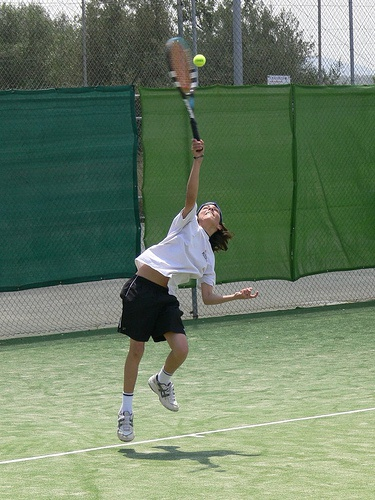Describe the objects in this image and their specific colors. I can see people in white, black, darkgray, and gray tones, tennis racket in white, gray, black, and darkgray tones, and sports ball in white, khaki, olive, and lightgreen tones in this image. 